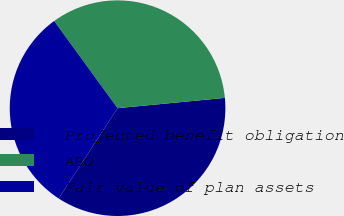Convert chart. <chart><loc_0><loc_0><loc_500><loc_500><pie_chart><fcel>Projected benefit obligation<fcel>ABO<fcel>Fair value of plan assets<nl><fcel>35.72%<fcel>33.49%<fcel>30.79%<nl></chart> 